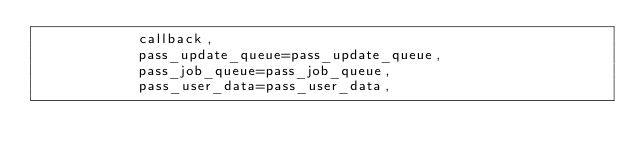<code> <loc_0><loc_0><loc_500><loc_500><_Python_>            callback,
            pass_update_queue=pass_update_queue,
            pass_job_queue=pass_job_queue,
            pass_user_data=pass_user_data,</code> 